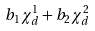<formula> <loc_0><loc_0><loc_500><loc_500>b _ { 1 } \chi ^ { 1 } _ { d } + b _ { 2 } \chi ^ { 2 } _ { d }</formula> 